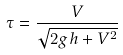Convert formula to latex. <formula><loc_0><loc_0><loc_500><loc_500>\tau = \frac { V } { \sqrt { 2 g h + V ^ { 2 } } }</formula> 